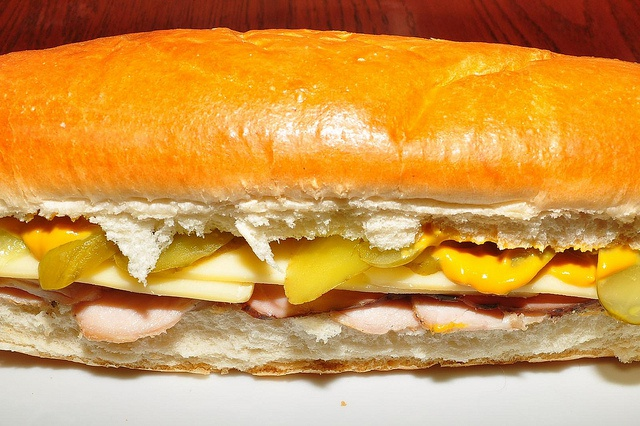Describe the objects in this image and their specific colors. I can see a sandwich in orange, maroon, and tan tones in this image. 